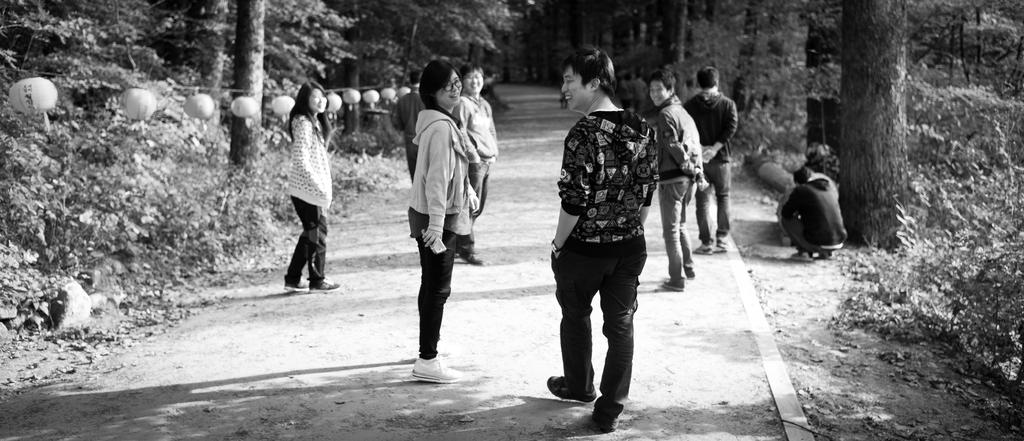What is happening on the road in the image? There is a group of people on the road in the image. What can be seen beside the road? There are paper lights with thread beside the road. What is visible in the background of the image? There are trees visible in the background of the image. What type of crate is being used to start a fire in the image? There is no crate or fire present in the image; it features a group of people on the road and paper lights with thread beside the road. What color is the collar on the dog in the image? There is no dog or collar present in the image. 